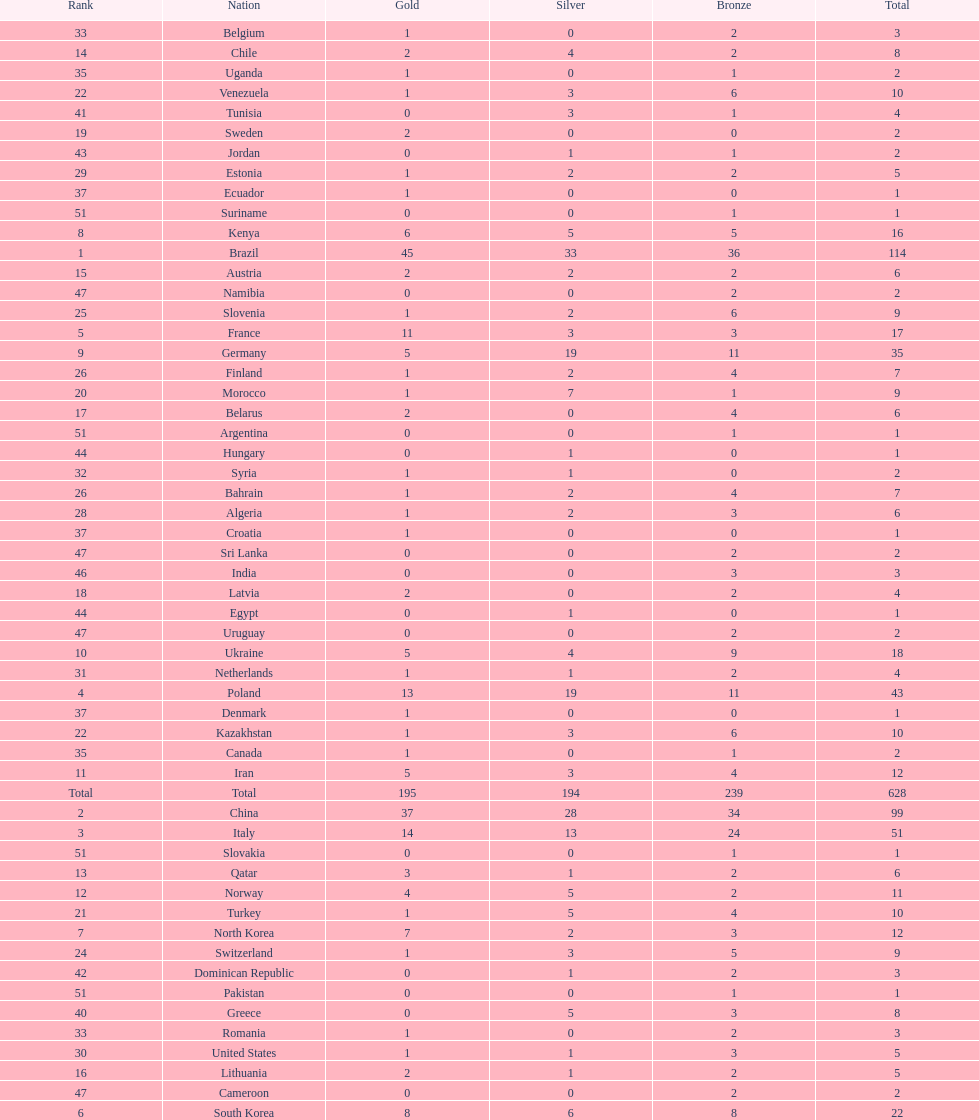South korea has how many more medals that north korea? 10. 